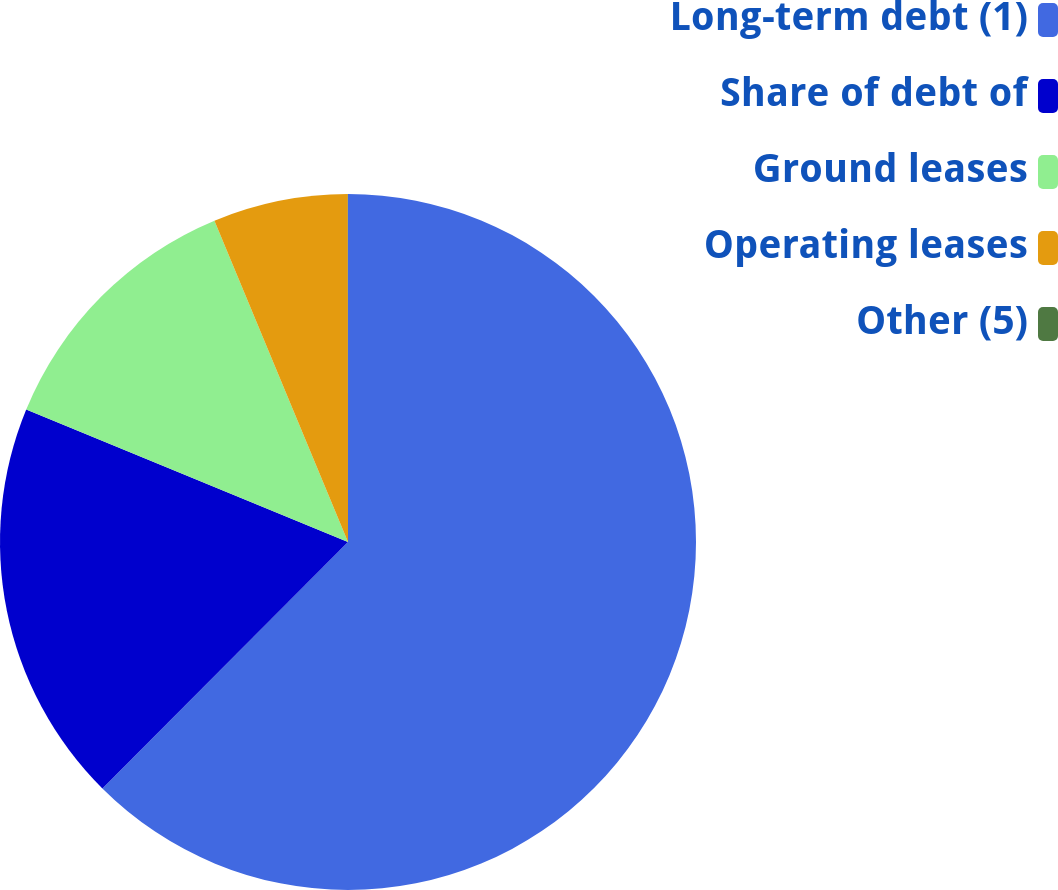Convert chart to OTSL. <chart><loc_0><loc_0><loc_500><loc_500><pie_chart><fcel>Long-term debt (1)<fcel>Share of debt of<fcel>Ground leases<fcel>Operating leases<fcel>Other (5)<nl><fcel>62.47%<fcel>18.75%<fcel>12.51%<fcel>6.26%<fcel>0.01%<nl></chart> 